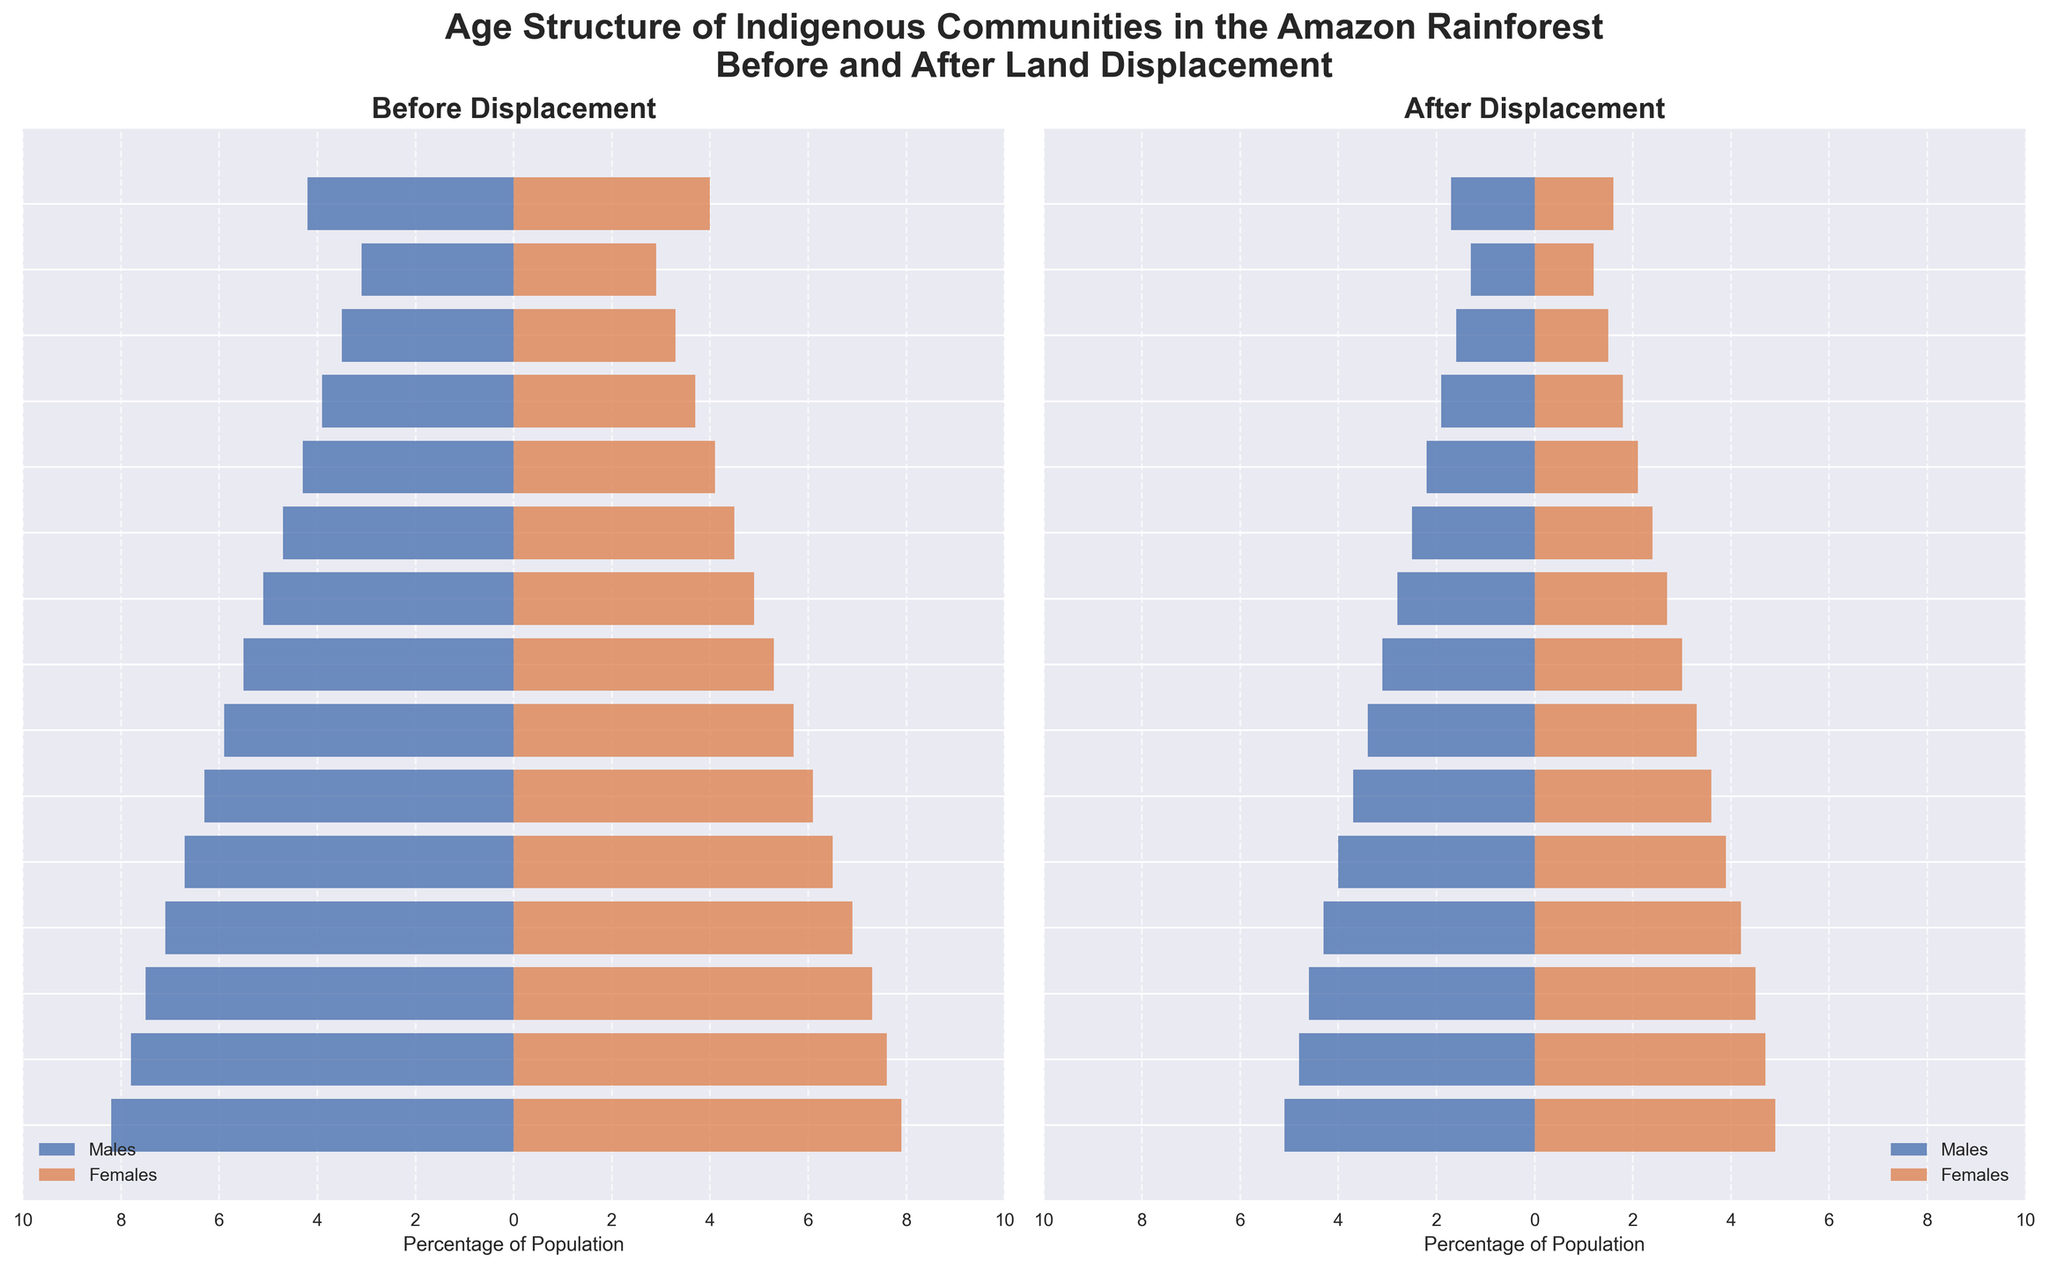What is the title of the figure? The title of the figure is displayed at the top and provides an overall description of the visualized data. It reads "Age Structure of Indigenous Communities in the Amazon Rainforest Before and After Land Displacement".
Answer: Age Structure of Indigenous Communities in the Amazon Rainforest Before and After Land Displacement Which age group has the highest population percentage for males before displacement? Look at the left bar chart for males (blue bars on the left) and find the age group with the longest bar. The age group 0-4 has the highest percentage of 8.2%.
Answer: 0-4 How does the population percentage of females ages 20-24 before displacement compare to after displacement? Compare the length of the bar for females in the 20-24 age group in both the left (before) and right (after) bar charts. Before displacement, it is 6.5%, and after displacement, it is 3.9%.
Answer: It decreased from 6.5% to 3.9% What is the total percentage of the population for both males and females in the 50-54 age group before displacement? Add the percentage of males and females in the 50-54 age group from the left bar chart. Males are 4.3% and females are 4.1%, so the total is 4.3% + 4.1%.
Answer: 8.4% Which age group experienced the largest reduction in population percentage for males after displacement? Compare the differences in bar lengths between the before (left) and after (right) bar charts. For males, the largest reduction is seen in the 0-4 age group, going from 8.2% to 5.1%, which is a reduction of 3.1 percentage points.
Answer: 0-4 What is the relative difference in the population percentage of males and females in the 40-44 age group after displacement? Subtract the population percentage of females from males within the 40-44 age group in the right bar chart. Males are 2.8% and females are 2.7%, so the relative difference is 2.8% - 2.7%.
Answer: 0.1% Are there any age groups where the population percentage of females is greater than males, and if so, which ones? Looking at the right and left bars of each age group in both charts, notice if the red (female) bar is longer than the blue (male) bar. In the 70+ age group before displacement, females have a slightly higher population percentage than males.
Answer: 70+ before displacement How did the percentage of the population in the 25-29 age group change after displacement for both genders? Look at the 25-29 age group in both charts. For males, it decreased from 6.3% before to 3.7% after. For females, it decreased from 6.1% before to 3.6% after.
Answer: Both males and females in the 25-29 age group saw a reduction in population percentage. Males reduced by 2.6 percentage points and females by 2.5 percentage points What is the total population percentage of individuals aged 55 and older after displacement? Sum the percentages of all age groups 55+ from the right bar charts. For males: 1.9% + 1.6% + 1.3% + 1.7%. For females: 1.8% + 1.5% + 1.2% + 1.6%. The total is (1.9 + 1.6 + 1.3 + 1.7 + 1.8 + 1.5 + 1.2 + 1.6)% = 12.6%.
Answer: 12.6% In which chart, before or after displacement, do females have a higher percentage population than males in the age group 70+? Compare the age group 70+ bars in both the before (left) and after (right) charts. Before displacement, females have a slightly higher percentage than males (4.0% vs 4.2%).
Answer: Before displacement 